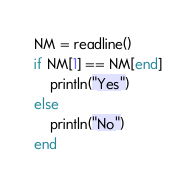Convert code to text. <code><loc_0><loc_0><loc_500><loc_500><_Julia_>NM = readline()
if NM[1] == NM[end]
    println("Yes")
else
    println("No")
end</code> 